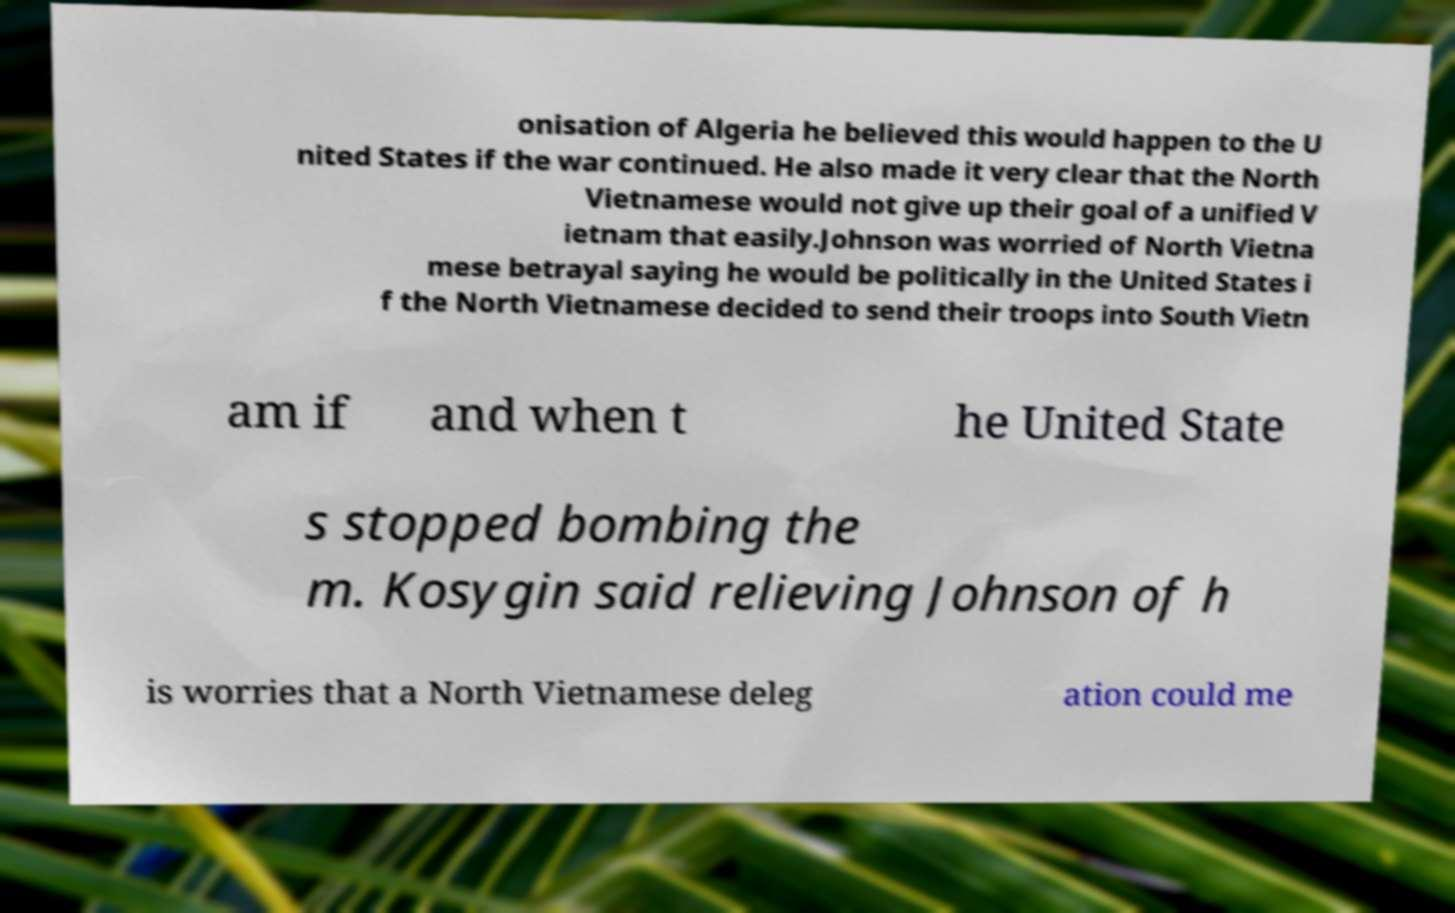I need the written content from this picture converted into text. Can you do that? onisation of Algeria he believed this would happen to the U nited States if the war continued. He also made it very clear that the North Vietnamese would not give up their goal of a unified V ietnam that easily.Johnson was worried of North Vietna mese betrayal saying he would be politically in the United States i f the North Vietnamese decided to send their troops into South Vietn am if and when t he United State s stopped bombing the m. Kosygin said relieving Johnson of h is worries that a North Vietnamese deleg ation could me 